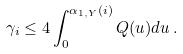Convert formula to latex. <formula><loc_0><loc_0><loc_500><loc_500>\gamma _ { i } \leq 4 \int _ { 0 } ^ { \alpha _ { 1 , { Y } } ( i ) } Q ( u ) d u \, .</formula> 